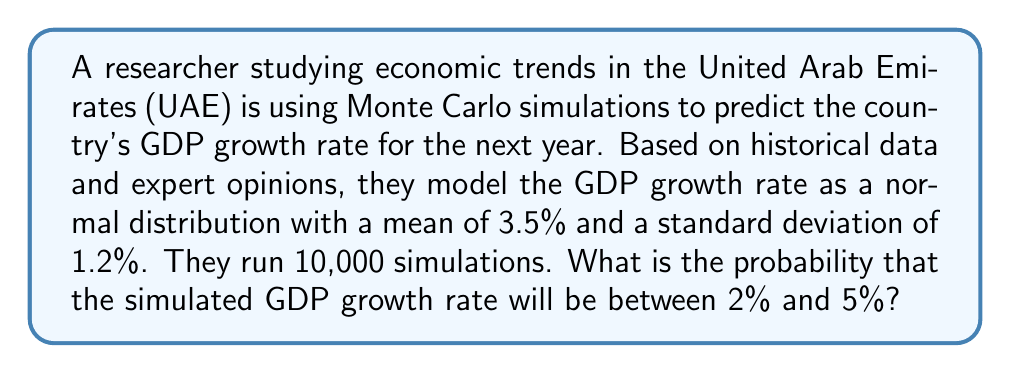What is the answer to this math problem? To solve this problem, we'll use the properties of the normal distribution and the concept of standardization:

1) First, we need to standardize the given range (2% to 5%) using the z-score formula:

   $z = \frac{x - \mu}{\sigma}$

   Where $x$ is the value, $\mu$ is the mean, and $\sigma$ is the standard deviation.

2) For the lower bound (2%):
   $z_1 = \frac{2 - 3.5}{1.2} = -1.25$

3) For the upper bound (5%):
   $z_2 = \frac{5 - 3.5}{1.2} = 1.25$

4) Now, we need to find the area under the standard normal curve between these two z-scores.

5) Using a standard normal distribution table or a calculator, we can find:
   $P(Z < 1.25) = 0.8944$
   $P(Z < -1.25) = 0.1056$

6) The probability we're looking for is the difference between these two:
   $P(-1.25 < Z < 1.25) = 0.8944 - 0.1056 = 0.7888$

7) Convert to a percentage:
   $0.7888 * 100 = 78.88\%$

Therefore, based on the Monte Carlo simulation, there is a 78.88% probability that the UAE's GDP growth rate will be between 2% and 5% next year.
Answer: 78.88% 